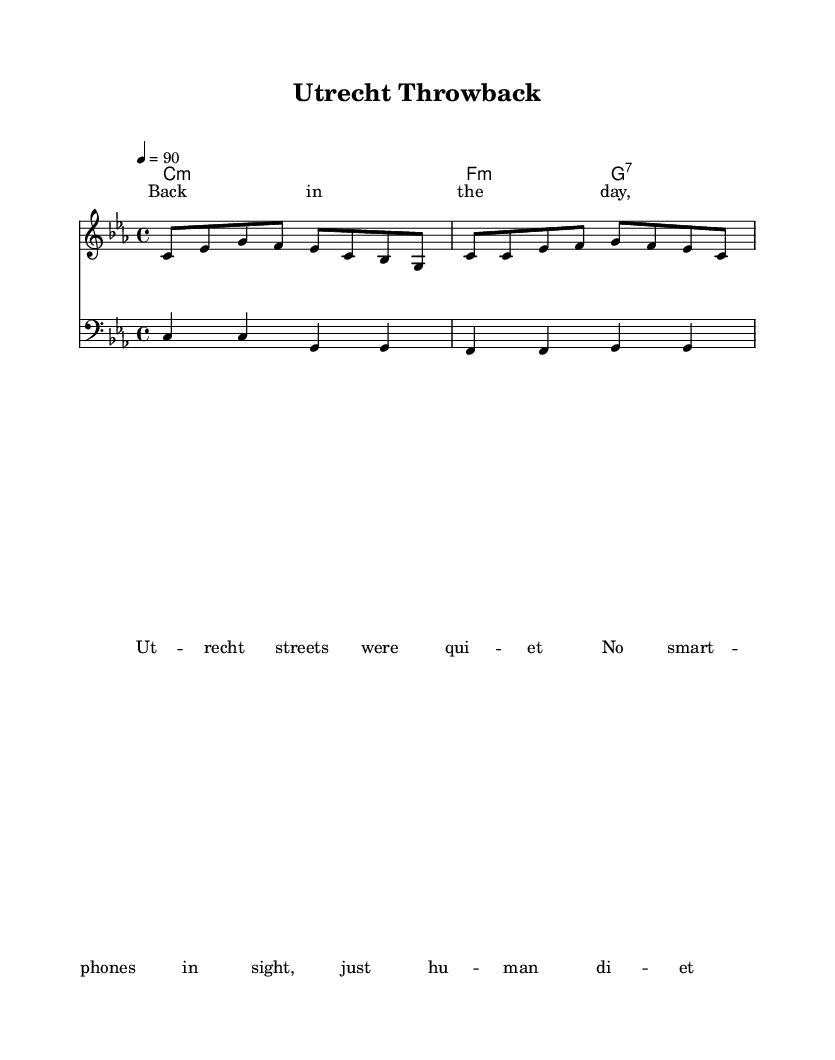What is the key signature of this music? The key signature indicates C minor, which has three flats (B flat, E flat, and A flat) as represented in the score.
Answer: C minor What is the time signature of the piece? The time signature displayed in the sheet music is 4/4, which means there are four beats per measure and a quarter note gets one beat.
Answer: 4/4 What is the tempo marking in the score? The tempo marking is indicated as quarter note equals 90, which denotes the speed at which the music should be played.
Answer: 90 How many measures are in the melody? By counting the groups separated by bar lines in the melody staff, we can see that there are four measures.
Answer: 4 What type of music is this piece classified as? The lyrics and structure of the music indicate that it is categorized as Rap, which often tells stories or reflects on experiences.
Answer: Rap What is the first lyric line of the verse? The first line in the lyrics section begins with "Back in the day," which sets the nostalgic tone for the song.
Answer: Back in the day What is the chord progression in the piece? The chord progression shown in the chord names part starts with C minor, transitioning to F minor, and then G7, typical for establishing a foundation in rap music.
Answer: C minor, F minor, G7 